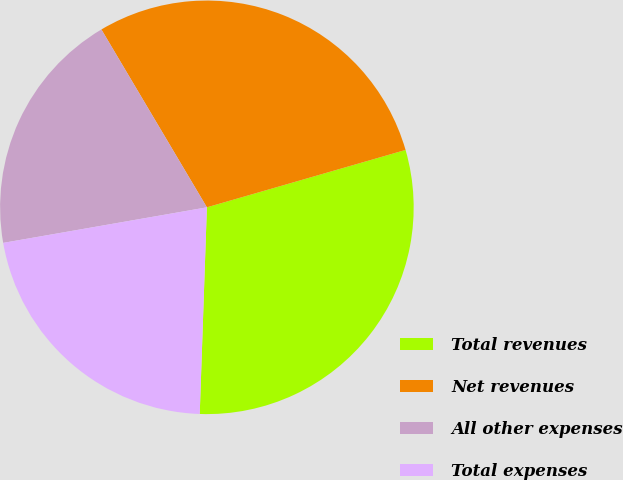Convert chart to OTSL. <chart><loc_0><loc_0><loc_500><loc_500><pie_chart><fcel>Total revenues<fcel>Net revenues<fcel>All other expenses<fcel>Total expenses<nl><fcel>30.03%<fcel>29.05%<fcel>19.23%<fcel>21.7%<nl></chart> 